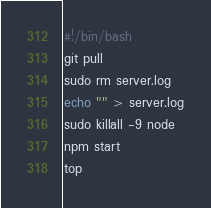<code> <loc_0><loc_0><loc_500><loc_500><_Bash_>#!/bin/bash
git pull
sudo rm server.log
echo "" > server.log
sudo killall -9 node
npm start
top</code> 